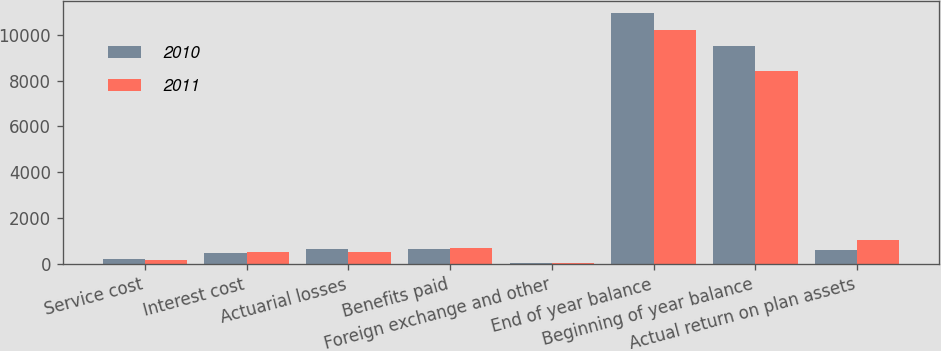Convert chart. <chart><loc_0><loc_0><loc_500><loc_500><stacked_bar_chart><ecel><fcel>Service cost<fcel>Interest cost<fcel>Actuarial losses<fcel>Benefits paid<fcel>Foreign exchange and other<fcel>End of year balance<fcel>Beginning of year balance<fcel>Actual return on plan assets<nl><fcel>2010<fcel>197<fcel>492<fcel>656<fcel>648<fcel>23<fcel>10925<fcel>9504<fcel>600<nl><fcel>2011<fcel>176<fcel>510<fcel>517<fcel>681<fcel>30<fcel>10197<fcel>8401<fcel>1054<nl></chart> 